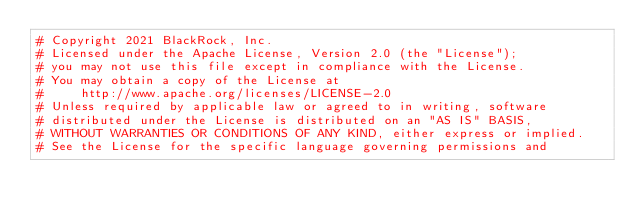Convert code to text. <code><loc_0><loc_0><loc_500><loc_500><_Python_># Copyright 2021 BlackRock, Inc.
# Licensed under the Apache License, Version 2.0 (the "License");
# you may not use this file except in compliance with the License.
# You may obtain a copy of the License at
#     http://www.apache.org/licenses/LICENSE-2.0
# Unless required by applicable law or agreed to in writing, software
# distributed under the License is distributed on an "AS IS" BASIS,
# WITHOUT WARRANTIES OR CONDITIONS OF ANY KIND, either express or implied.
# See the License for the specific language governing permissions and</code> 